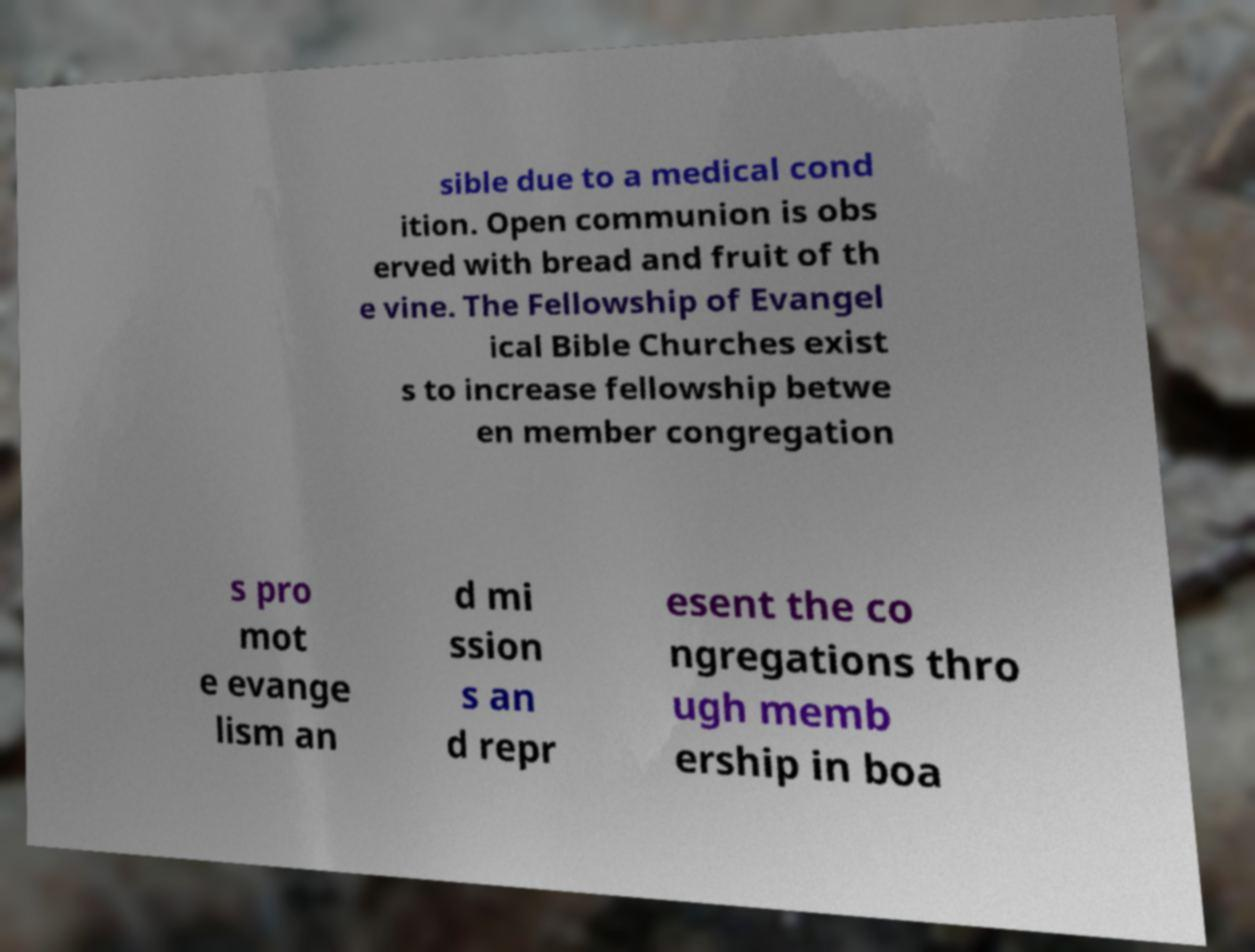For documentation purposes, I need the text within this image transcribed. Could you provide that? sible due to a medical cond ition. Open communion is obs erved with bread and fruit of th e vine. The Fellowship of Evangel ical Bible Churches exist s to increase fellowship betwe en member congregation s pro mot e evange lism an d mi ssion s an d repr esent the co ngregations thro ugh memb ership in boa 